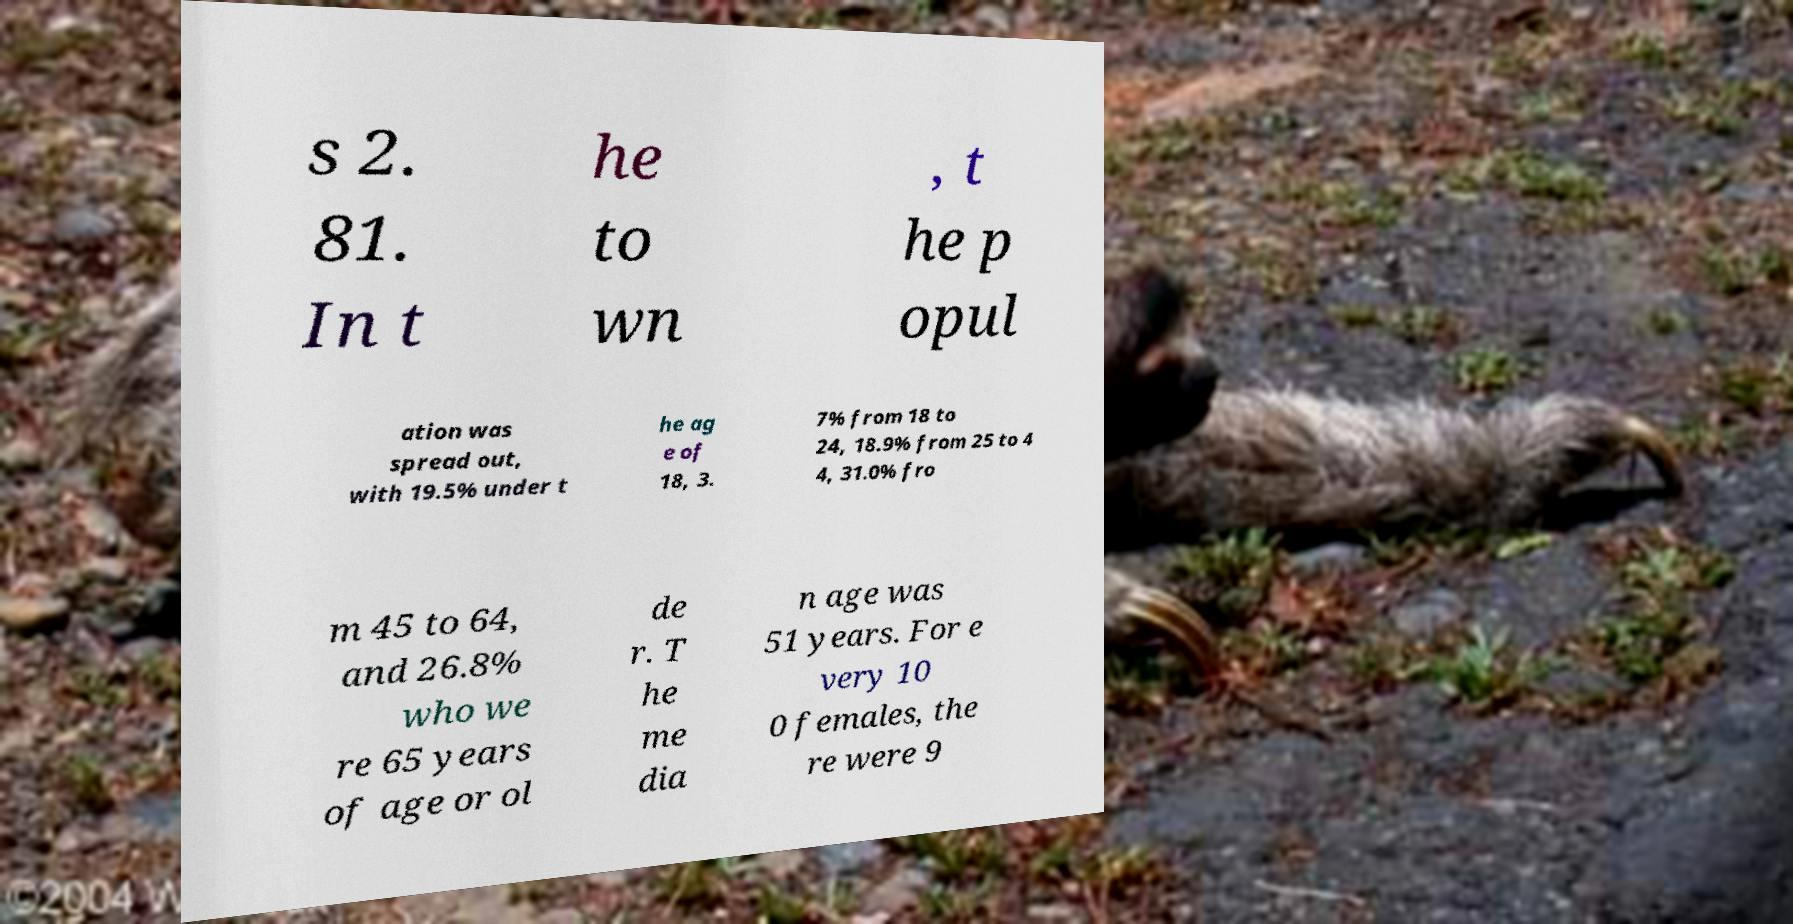There's text embedded in this image that I need extracted. Can you transcribe it verbatim? s 2. 81. In t he to wn , t he p opul ation was spread out, with 19.5% under t he ag e of 18, 3. 7% from 18 to 24, 18.9% from 25 to 4 4, 31.0% fro m 45 to 64, and 26.8% who we re 65 years of age or ol de r. T he me dia n age was 51 years. For e very 10 0 females, the re were 9 